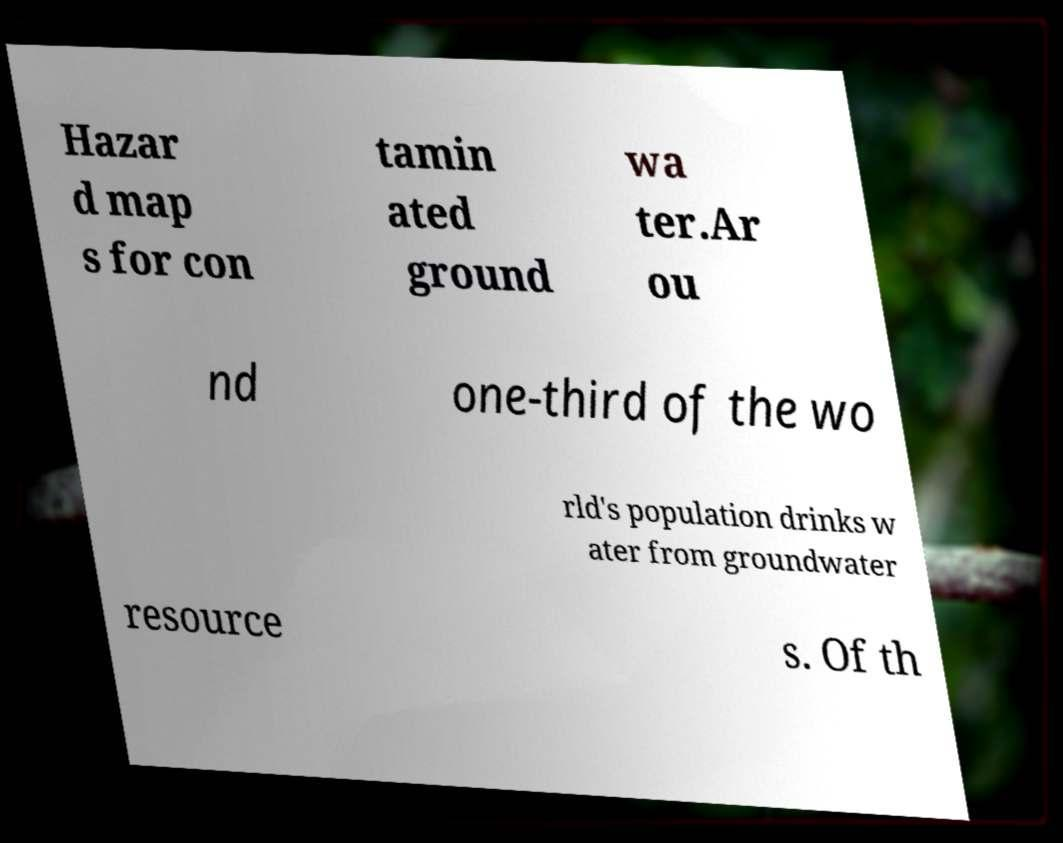Could you extract and type out the text from this image? Hazar d map s for con tamin ated ground wa ter.Ar ou nd one-third of the wo rld's population drinks w ater from groundwater resource s. Of th 